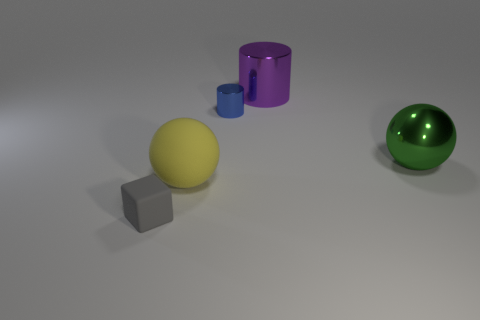Do the big yellow matte object and the large green thing have the same shape?
Offer a very short reply. Yes. What number of gray rubber objects are the same shape as the purple thing?
Your answer should be compact. 0. There is a tiny block; what number of large things are behind it?
Provide a short and direct response. 3. There is a tiny thing to the right of the small gray cube; does it have the same color as the small matte thing?
Keep it short and to the point. No. What number of red matte balls have the same size as the purple cylinder?
Your answer should be compact. 0. What is the shape of the yellow object that is the same material as the gray cube?
Offer a terse response. Sphere. Is there a tiny block of the same color as the big rubber ball?
Make the answer very short. No. What material is the cube?
Keep it short and to the point. Rubber. How many things are cyan blocks or small shiny things?
Give a very brief answer. 1. There is a sphere in front of the metallic sphere; how big is it?
Make the answer very short. Large. 